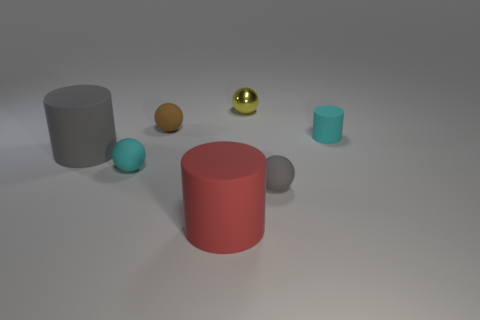Can you describe the lighting and shadows in the scene? The lighting in the scene appears to be diffused, likely from an overhead source, as indicated by the soft shadows cast by the objects. The shadows lie mostly to the right of the objects, suggesting the light source is to the upper left. There is no harsh contrast, indicating the light is not extremely strong, or it's being softened, possibly by a filter or ambient occlusion. The smoothness of the shadows helps to convey the 3D form of the objects by subtly showing their curves and edges. 